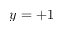Convert formula to latex. <formula><loc_0><loc_0><loc_500><loc_500>y = + 1</formula> 